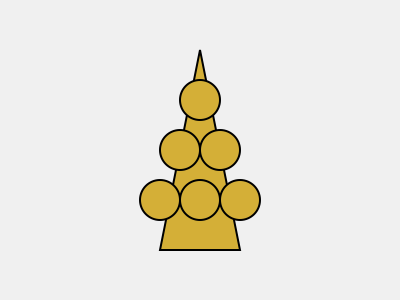The menorah depicted in the image is a powerful symbol in Judaism. How does its structure relate to the concept of divine light, and what significance does this hold for those who have experienced profound darkness? 1. Structure of the menorah:
   - The menorah has seven branches, with one central stem and three on each side.
   - This structure is based on the description in Exodus 25:31-40.

2. Symbolism of light:
   - In Judaism, light represents divine wisdom, knowledge, and guidance.
   - The seven branches symbolize the seven days of creation, with the central stem representing the Sabbath.

3. Divine light concept:
   - The menorah's light symbolizes God's presence and the illumination of spiritual darkness.
   - It represents hope, enlightenment, and the triumph of good over evil.

4. Significance for those who experienced darkness:
   - For Holocaust survivors, the menorah's light can symbolize resilience and hope in the face of unimaginable darkness.
   - It serves as a reminder of faith's enduring power and the possibility of spiritual renewal.

5. Personal connection:
   - For an elderly Holocaust survivor, the menorah's light may represent the guidance and comfort found in religious teachings and community.
   - It can serve as a powerful symbol of survival and the continuity of Jewish tradition despite attempts at destruction.

6. Broader implications:
   - The menorah's light spreading outward symbolizes the Jewish mission to be a "light unto the nations" (Isaiah 49:6).
   - This concept emphasizes the importance of sharing wisdom, compassion, and moral guidance with the world.
Answer: The menorah's seven-branched structure symbolizes divine light, representing hope, wisdom, and spiritual resilience for those who have experienced profound darkness. 